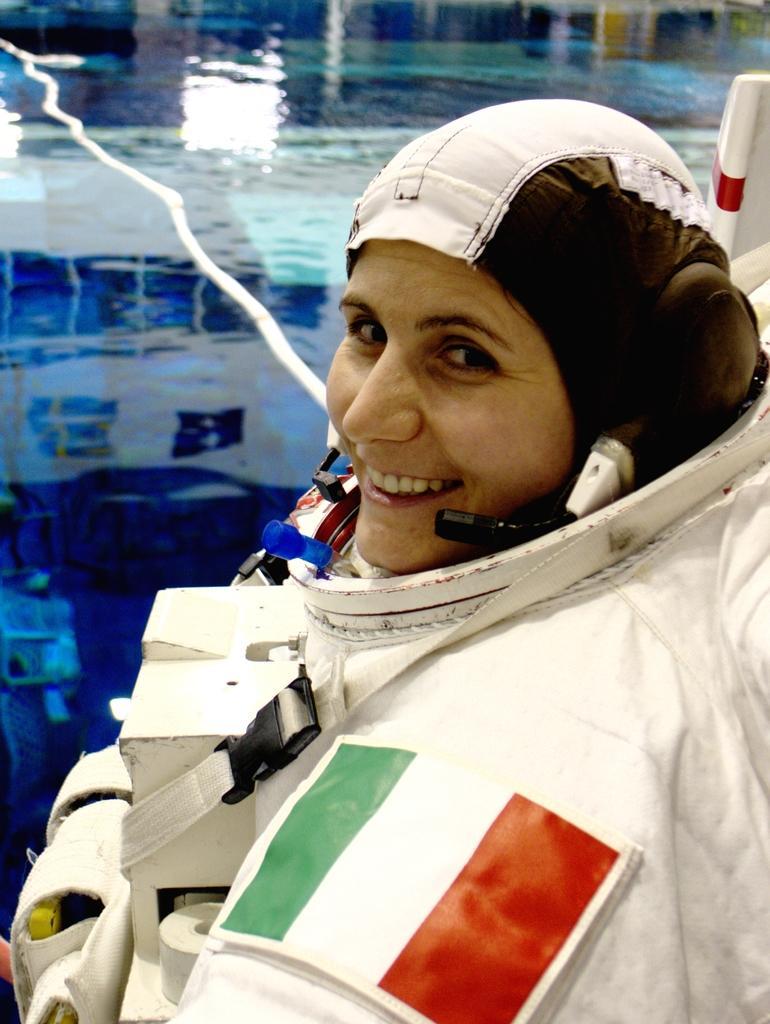Could you give a brief overview of what you see in this image? In the center of the image we can see a lady is smiling and wearing a dress, headset. In the background of the image we can see the water. 